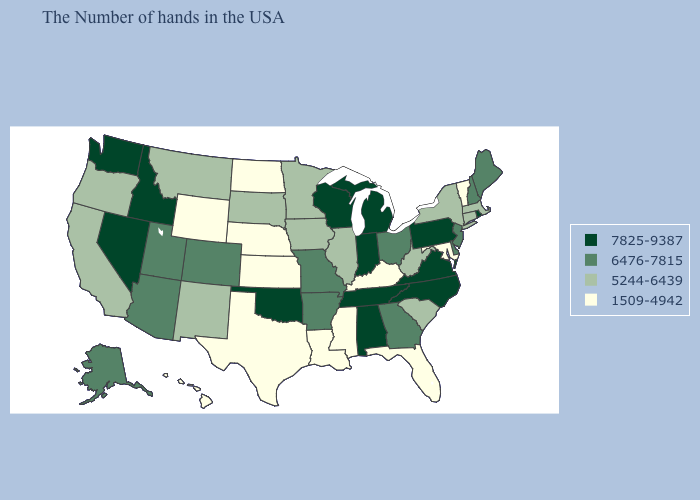What is the value of California?
Concise answer only. 5244-6439. Does South Dakota have a lower value than Louisiana?
Keep it brief. No. Name the states that have a value in the range 1509-4942?
Concise answer only. Vermont, Maryland, Florida, Kentucky, Mississippi, Louisiana, Kansas, Nebraska, Texas, North Dakota, Wyoming, Hawaii. Does Louisiana have the lowest value in the USA?
Quick response, please. Yes. Does Vermont have the lowest value in the Northeast?
Short answer required. Yes. What is the value of Mississippi?
Quick response, please. 1509-4942. Which states have the highest value in the USA?
Write a very short answer. Rhode Island, Pennsylvania, Virginia, North Carolina, Michigan, Indiana, Alabama, Tennessee, Wisconsin, Oklahoma, Idaho, Nevada, Washington. Does Arkansas have the lowest value in the USA?
Quick response, please. No. Does Oklahoma have the highest value in the USA?
Concise answer only. Yes. Among the states that border Connecticut , which have the lowest value?
Write a very short answer. Massachusetts, New York. Does Oklahoma have the same value as Alabama?
Be succinct. Yes. What is the value of Oklahoma?
Concise answer only. 7825-9387. What is the value of Michigan?
Give a very brief answer. 7825-9387. Among the states that border Connecticut , which have the lowest value?
Concise answer only. Massachusetts, New York. Name the states that have a value in the range 6476-7815?
Write a very short answer. Maine, New Hampshire, New Jersey, Delaware, Ohio, Georgia, Missouri, Arkansas, Colorado, Utah, Arizona, Alaska. 